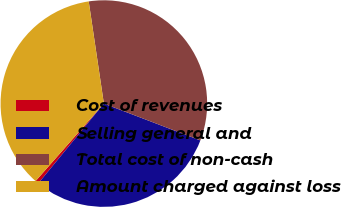Convert chart to OTSL. <chart><loc_0><loc_0><loc_500><loc_500><pie_chart><fcel>Cost of revenues<fcel>Selling general and<fcel>Total cost of non-cash<fcel>Amount charged against loss<nl><fcel>0.55%<fcel>30.14%<fcel>33.15%<fcel>36.16%<nl></chart> 